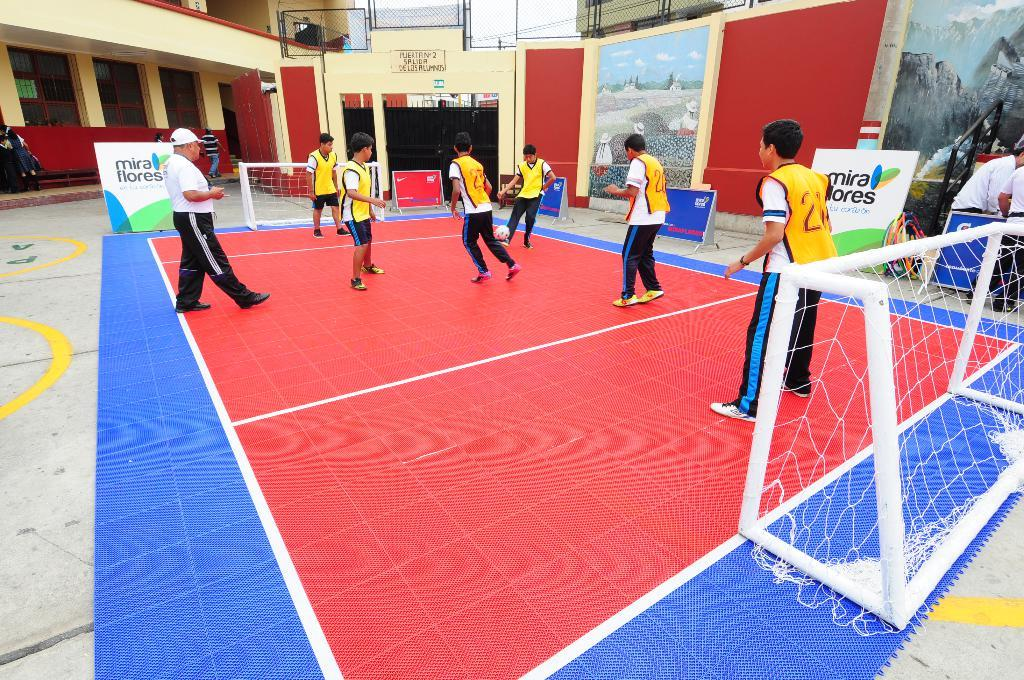What is the color of the ground where the people are standing? The ground where the people are standing is red in color. What is the purpose of the net in the image? The net is likely used for a game or sport, as it is on either side of the people. What can be seen in the background of the image? There is a building and other objects visible in the background of the image. What type of dirt is being used for the operation in the image? There is no operation or dirt present in the image; it features people standing on a red ground with a net on either side. 